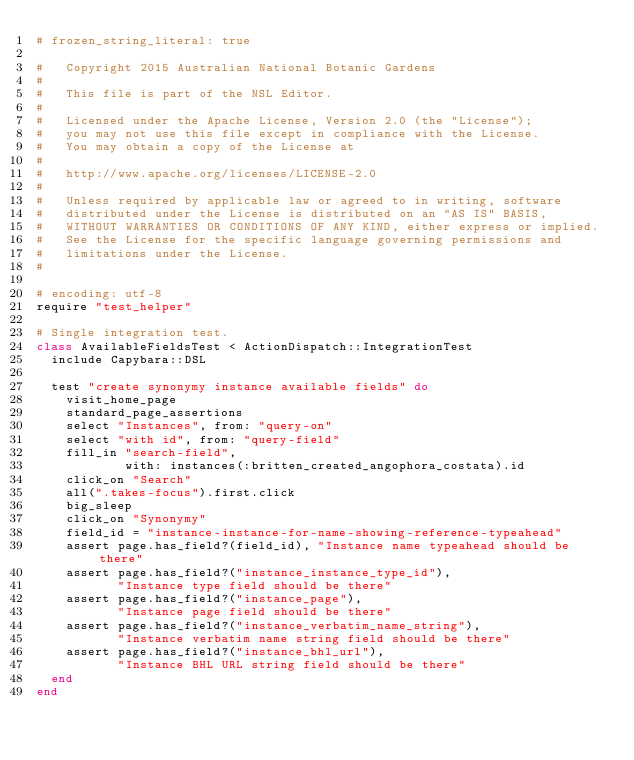Convert code to text. <code><loc_0><loc_0><loc_500><loc_500><_Ruby_># frozen_string_literal: true

#   Copyright 2015 Australian National Botanic Gardens
#
#   This file is part of the NSL Editor.
#
#   Licensed under the Apache License, Version 2.0 (the "License");
#   you may not use this file except in compliance with the License.
#   You may obtain a copy of the License at
#
#   http://www.apache.org/licenses/LICENSE-2.0
#
#   Unless required by applicable law or agreed to in writing, software
#   distributed under the License is distributed on an "AS IS" BASIS,
#   WITHOUT WARRANTIES OR CONDITIONS OF ANY KIND, either express or implied.
#   See the License for the specific language governing permissions and
#   limitations under the License.
#

# encoding: utf-8
require "test_helper"

# Single integration test.
class AvailableFieldsTest < ActionDispatch::IntegrationTest
  include Capybara::DSL

  test "create synonymy instance available fields" do
    visit_home_page
    standard_page_assertions
    select "Instances", from: "query-on"
    select "with id", from: "query-field"
    fill_in "search-field",
            with: instances(:britten_created_angophora_costata).id
    click_on "Search"
    all(".takes-focus").first.click
    big_sleep
    click_on "Synonymy"
    field_id = "instance-instance-for-name-showing-reference-typeahead"
    assert page.has_field?(field_id), "Instance name typeahead should be there"
    assert page.has_field?("instance_instance_type_id"),
           "Instance type field should be there"
    assert page.has_field?("instance_page"),
           "Instance page field should be there"
    assert page.has_field?("instance_verbatim_name_string"),
           "Instance verbatim name string field should be there"
    assert page.has_field?("instance_bhl_url"),
           "Instance BHL URL string field should be there"
  end
end
</code> 